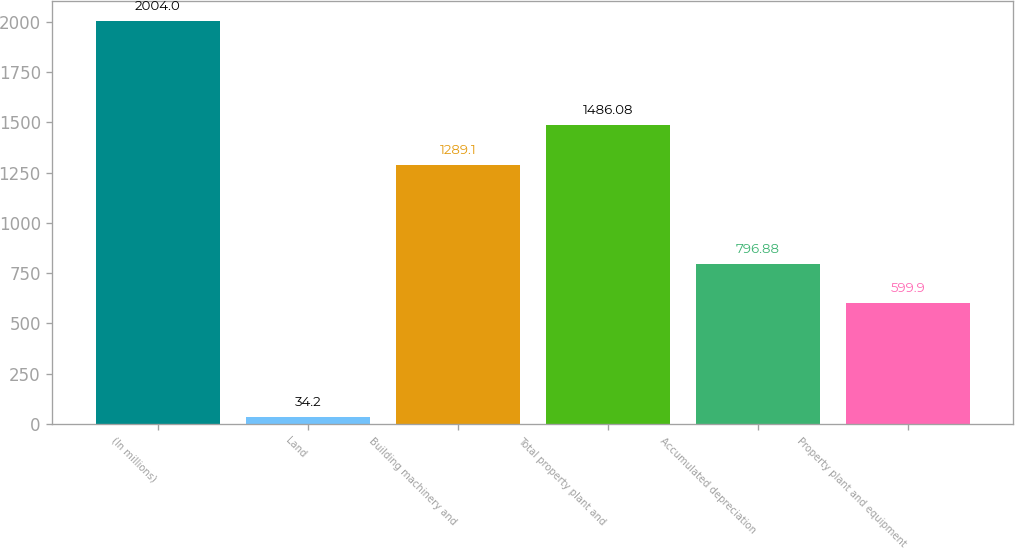Convert chart. <chart><loc_0><loc_0><loc_500><loc_500><bar_chart><fcel>(In millions)<fcel>Land<fcel>Building machinery and<fcel>Total property plant and<fcel>Accumulated depreciation<fcel>Property plant and equipment<nl><fcel>2004<fcel>34.2<fcel>1289.1<fcel>1486.08<fcel>796.88<fcel>599.9<nl></chart> 